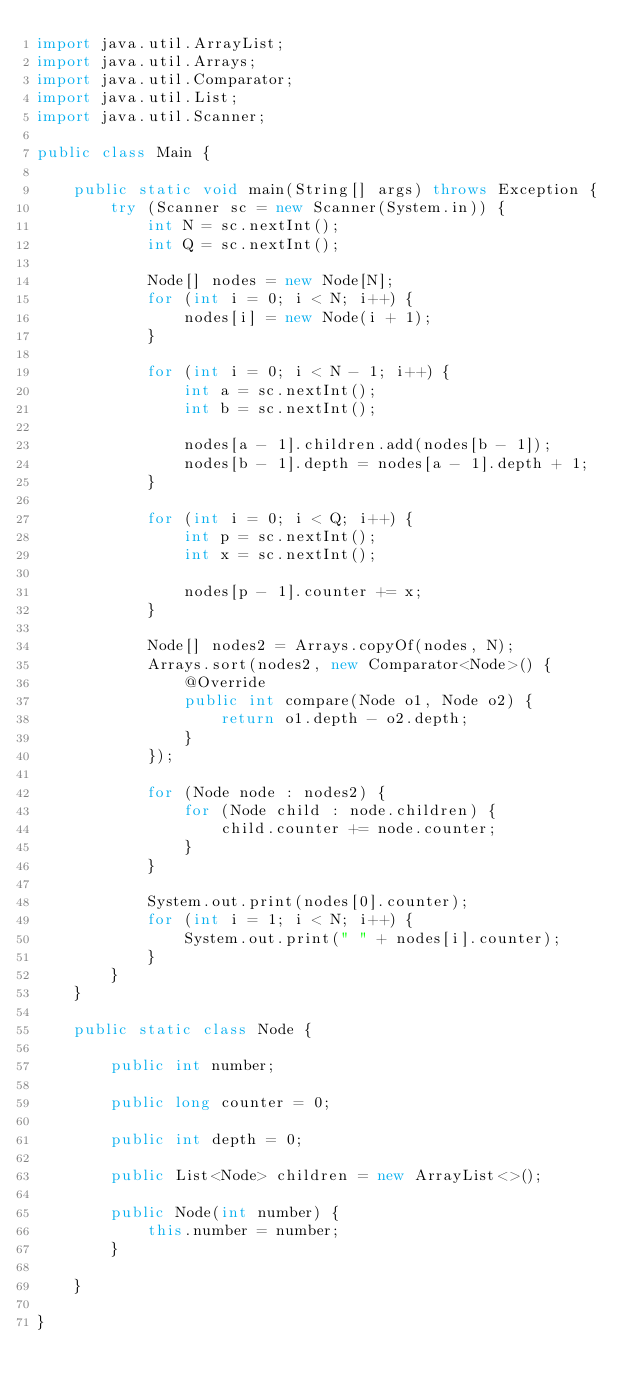<code> <loc_0><loc_0><loc_500><loc_500><_Java_>import java.util.ArrayList;
import java.util.Arrays;
import java.util.Comparator;
import java.util.List;
import java.util.Scanner;

public class Main {

    public static void main(String[] args) throws Exception {
        try (Scanner sc = new Scanner(System.in)) {
            int N = sc.nextInt();
            int Q = sc.nextInt();

            Node[] nodes = new Node[N];
            for (int i = 0; i < N; i++) {
                nodes[i] = new Node(i + 1);
            }

            for (int i = 0; i < N - 1; i++) {
                int a = sc.nextInt();
                int b = sc.nextInt();

                nodes[a - 1].children.add(nodes[b - 1]);
                nodes[b - 1].depth = nodes[a - 1].depth + 1;
            }

            for (int i = 0; i < Q; i++) {
                int p = sc.nextInt();
                int x = sc.nextInt();

                nodes[p - 1].counter += x;
            }

            Node[] nodes2 = Arrays.copyOf(nodes, N);
            Arrays.sort(nodes2, new Comparator<Node>() {
                @Override
                public int compare(Node o1, Node o2) {
                    return o1.depth - o2.depth;
                }
            });

            for (Node node : nodes2) {
                for (Node child : node.children) {
                    child.counter += node.counter;
                }
            }

            System.out.print(nodes[0].counter);
            for (int i = 1; i < N; i++) {
                System.out.print(" " + nodes[i].counter);
            }
        }
    }

    public static class Node {

        public int number;

        public long counter = 0;

        public int depth = 0;

        public List<Node> children = new ArrayList<>();

        public Node(int number) {
            this.number = number;
        }

    }

}
</code> 